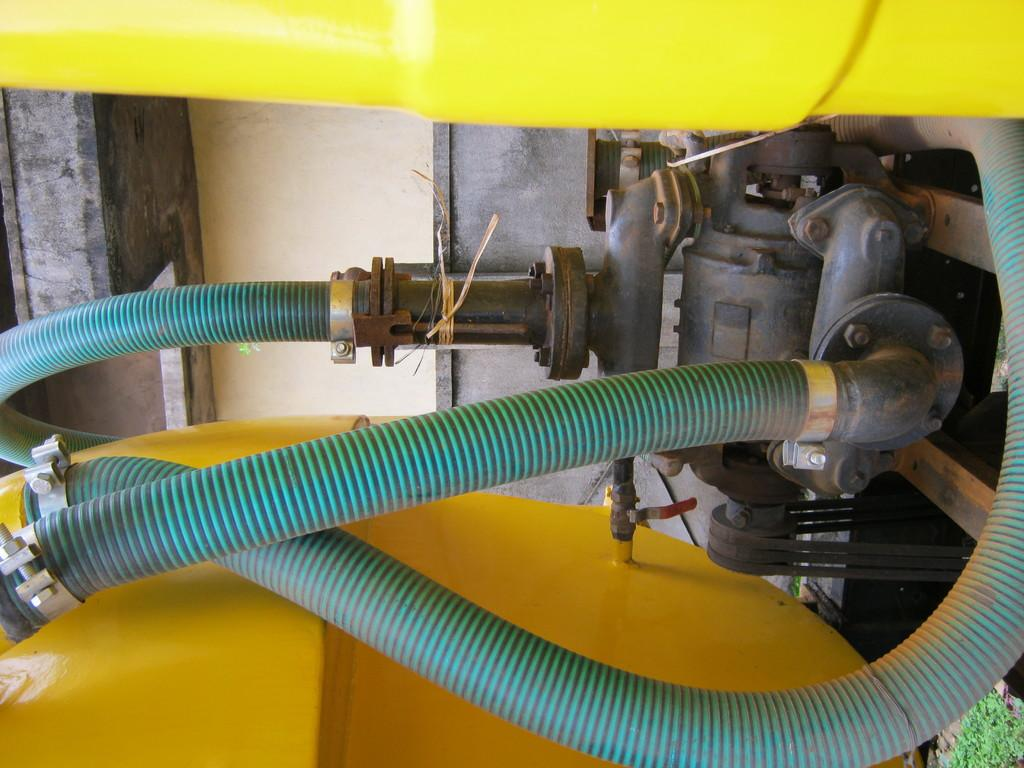What is the main object in the image? There is a motor in the image. What other objects are visible in the image? There are pipes in the image. What can be seen in the background of the image? There is a wall in the background of the image. Is there any vegetation or greenery in the image? Yes, there appears to be a plant in the bottom right corner of the image. How many icicles are hanging from the motor in the image? There are no icicles present in the image. Can you see any rabbits interacting with the motor in the image? There are no rabbits present in the image. 